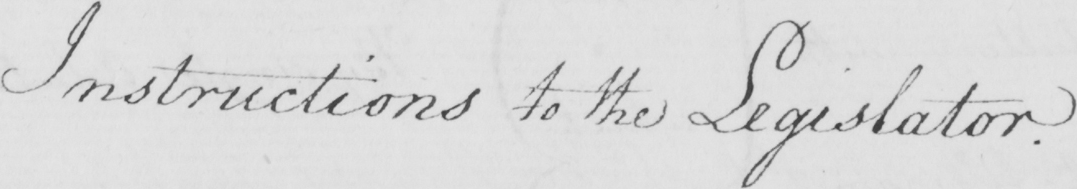Can you tell me what this handwritten text says? Instructions to the Legislator . 